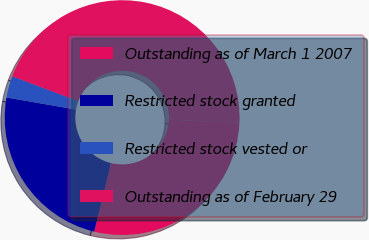Convert chart to OTSL. <chart><loc_0><loc_0><loc_500><loc_500><pie_chart><fcel>Outstanding as of March 1 2007<fcel>Restricted stock granted<fcel>Restricted stock vested or<fcel>Outstanding as of February 29<nl><fcel>28.12%<fcel>23.92%<fcel>2.98%<fcel>44.99%<nl></chart> 